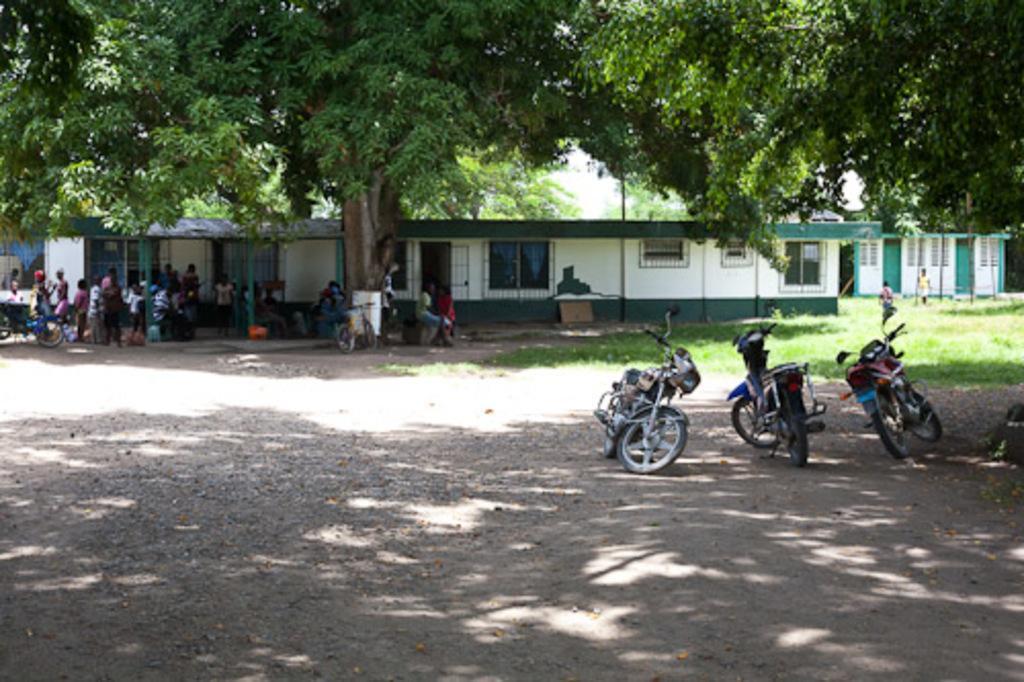Please provide a concise description of this image. In this image I can see vehicles on the road. Back I can see building,glass windows and trees. I can see few people around. The building is in white and green color. 